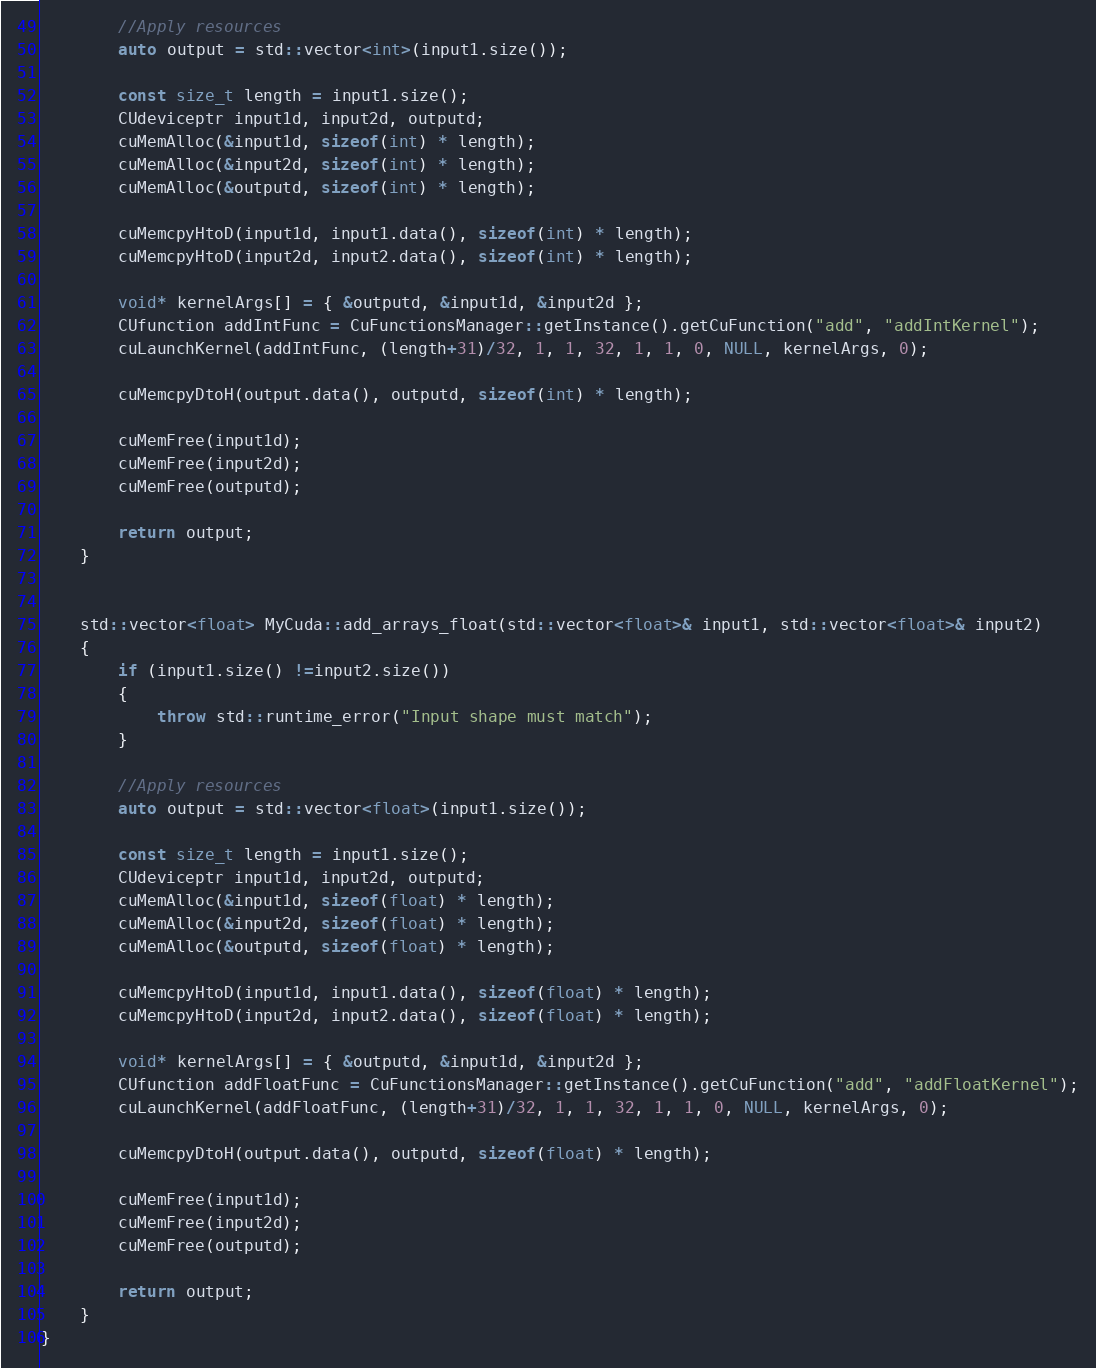Convert code to text. <code><loc_0><loc_0><loc_500><loc_500><_C++_>
        //Apply resources
        auto output = std::vector<int>(input1.size());

        const size_t length = input1.size();
        CUdeviceptr input1d, input2d, outputd;
        cuMemAlloc(&input1d, sizeof(int) * length);
        cuMemAlloc(&input2d, sizeof(int) * length);
        cuMemAlloc(&outputd, sizeof(int) * length);

        cuMemcpyHtoD(input1d, input1.data(), sizeof(int) * length);
        cuMemcpyHtoD(input2d, input2.data(), sizeof(int) * length);

        void* kernelArgs[] = { &outputd, &input1d, &input2d };
        CUfunction addIntFunc = CuFunctionsManager::getInstance().getCuFunction("add", "addIntKernel");
        cuLaunchKernel(addIntFunc, (length+31)/32, 1, 1, 32, 1, 1, 0, NULL, kernelArgs, 0);

        cuMemcpyDtoH(output.data(), outputd, sizeof(int) * length);

        cuMemFree(input1d);
        cuMemFree(input2d);
        cuMemFree(outputd);

        return output;
    }


    std::vector<float> MyCuda::add_arrays_float(std::vector<float>& input1, std::vector<float>& input2)
    {
        if (input1.size() !=input2.size())
        {
            throw std::runtime_error("Input shape must match");
        }

        //Apply resources
        auto output = std::vector<float>(input1.size());

        const size_t length = input1.size();
        CUdeviceptr input1d, input2d, outputd;
        cuMemAlloc(&input1d, sizeof(float) * length);
        cuMemAlloc(&input2d, sizeof(float) * length);
        cuMemAlloc(&outputd, sizeof(float) * length);

        cuMemcpyHtoD(input1d, input1.data(), sizeof(float) * length);
        cuMemcpyHtoD(input2d, input2.data(), sizeof(float) * length);

        void* kernelArgs[] = { &outputd, &input1d, &input2d };
        CUfunction addFloatFunc = CuFunctionsManager::getInstance().getCuFunction("add", "addFloatKernel");
        cuLaunchKernel(addFloatFunc, (length+31)/32, 1, 1, 32, 1, 1, 0, NULL, kernelArgs, 0);

        cuMemcpyDtoH(output.data(), outputd, sizeof(float) * length);

        cuMemFree(input1d);
        cuMemFree(input2d);
        cuMemFree(outputd);

        return output;
    }
}</code> 